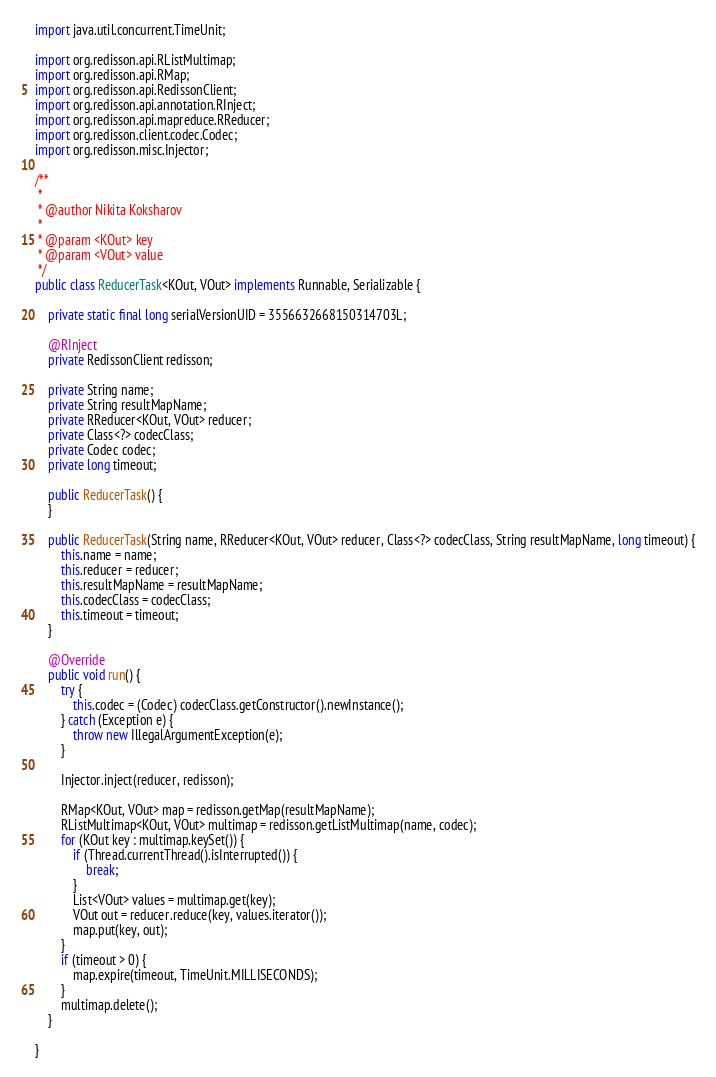Convert code to text. <code><loc_0><loc_0><loc_500><loc_500><_Java_>import java.util.concurrent.TimeUnit;

import org.redisson.api.RListMultimap;
import org.redisson.api.RMap;
import org.redisson.api.RedissonClient;
import org.redisson.api.annotation.RInject;
import org.redisson.api.mapreduce.RReducer;
import org.redisson.client.codec.Codec;
import org.redisson.misc.Injector;

/**
 * 
 * @author Nikita Koksharov
 *
 * @param <KOut> key
 * @param <VOut> value
 */
public class ReducerTask<KOut, VOut> implements Runnable, Serializable {

    private static final long serialVersionUID = 3556632668150314703L;

    @RInject
    private RedissonClient redisson;
    
    private String name;
    private String resultMapName;
    private RReducer<KOut, VOut> reducer;
    private Class<?> codecClass;
    private Codec codec;
    private long timeout;

    public ReducerTask() {
    }
    
    public ReducerTask(String name, RReducer<KOut, VOut> reducer, Class<?> codecClass, String resultMapName, long timeout) {
        this.name = name;
        this.reducer = reducer;
        this.resultMapName = resultMapName;
        this.codecClass = codecClass;
        this.timeout = timeout;
    }

    @Override
    public void run() {
        try {
            this.codec = (Codec) codecClass.getConstructor().newInstance();
        } catch (Exception e) {
            throw new IllegalArgumentException(e);
        }
        
        Injector.inject(reducer, redisson);
        
        RMap<KOut, VOut> map = redisson.getMap(resultMapName);
        RListMultimap<KOut, VOut> multimap = redisson.getListMultimap(name, codec);
        for (KOut key : multimap.keySet()) {
            if (Thread.currentThread().isInterrupted()) {
                break;
            }
            List<VOut> values = multimap.get(key);
            VOut out = reducer.reduce(key, values.iterator());
            map.put(key, out);
        }
        if (timeout > 0) {
            map.expire(timeout, TimeUnit.MILLISECONDS);
        }
        multimap.delete();
    }

}
</code> 